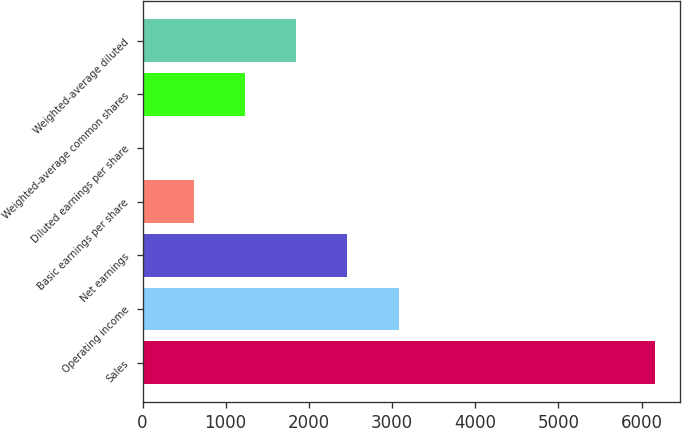Convert chart. <chart><loc_0><loc_0><loc_500><loc_500><bar_chart><fcel>Sales<fcel>Operating income<fcel>Net earnings<fcel>Basic earnings per share<fcel>Diluted earnings per share<fcel>Weighted-average common shares<fcel>Weighted-average diluted<nl><fcel>6157<fcel>3079.57<fcel>2464.08<fcel>617.61<fcel>2.12<fcel>1233.1<fcel>1848.59<nl></chart> 